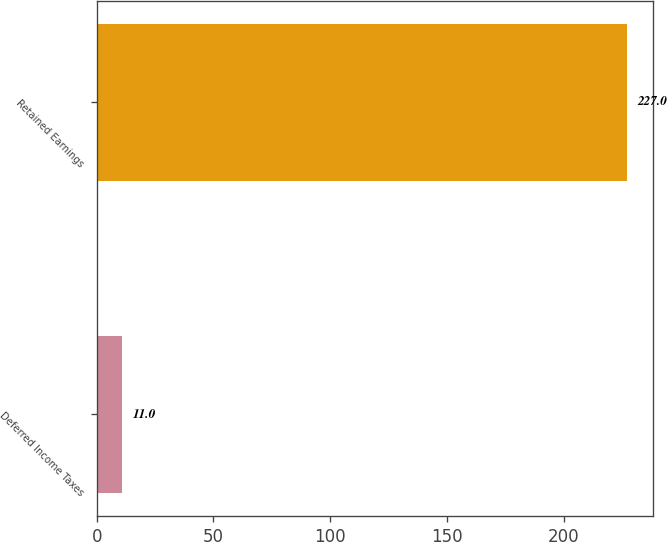<chart> <loc_0><loc_0><loc_500><loc_500><bar_chart><fcel>Deferred Income Taxes<fcel>Retained Earnings<nl><fcel>11<fcel>227<nl></chart> 